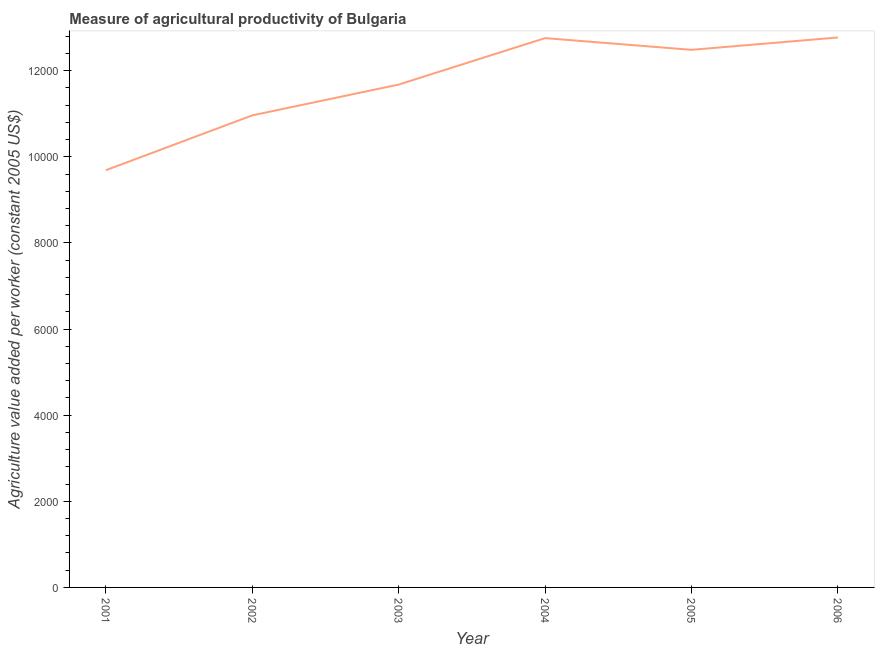What is the agriculture value added per worker in 2006?
Offer a very short reply. 1.28e+04. Across all years, what is the maximum agriculture value added per worker?
Provide a short and direct response. 1.28e+04. Across all years, what is the minimum agriculture value added per worker?
Offer a very short reply. 9690.22. In which year was the agriculture value added per worker maximum?
Give a very brief answer. 2006. What is the sum of the agriculture value added per worker?
Give a very brief answer. 7.04e+04. What is the difference between the agriculture value added per worker in 2001 and 2005?
Provide a short and direct response. -2795.65. What is the average agriculture value added per worker per year?
Offer a terse response. 1.17e+04. What is the median agriculture value added per worker?
Your response must be concise. 1.21e+04. In how many years, is the agriculture value added per worker greater than 5200 US$?
Make the answer very short. 6. Do a majority of the years between 2004 and 2003 (inclusive) have agriculture value added per worker greater than 6400 US$?
Your response must be concise. No. What is the ratio of the agriculture value added per worker in 2001 to that in 2005?
Your answer should be compact. 0.78. Is the agriculture value added per worker in 2001 less than that in 2005?
Give a very brief answer. Yes. What is the difference between the highest and the second highest agriculture value added per worker?
Give a very brief answer. 14.93. What is the difference between the highest and the lowest agriculture value added per worker?
Your answer should be compact. 3083.1. In how many years, is the agriculture value added per worker greater than the average agriculture value added per worker taken over all years?
Your answer should be very brief. 3. Does the agriculture value added per worker monotonically increase over the years?
Ensure brevity in your answer.  No. How many lines are there?
Give a very brief answer. 1. How many years are there in the graph?
Give a very brief answer. 6. What is the difference between two consecutive major ticks on the Y-axis?
Make the answer very short. 2000. Are the values on the major ticks of Y-axis written in scientific E-notation?
Make the answer very short. No. Does the graph contain any zero values?
Provide a succinct answer. No. What is the title of the graph?
Give a very brief answer. Measure of agricultural productivity of Bulgaria. What is the label or title of the Y-axis?
Keep it short and to the point. Agriculture value added per worker (constant 2005 US$). What is the Agriculture value added per worker (constant 2005 US$) in 2001?
Offer a terse response. 9690.22. What is the Agriculture value added per worker (constant 2005 US$) of 2002?
Ensure brevity in your answer.  1.10e+04. What is the Agriculture value added per worker (constant 2005 US$) in 2003?
Ensure brevity in your answer.  1.17e+04. What is the Agriculture value added per worker (constant 2005 US$) of 2004?
Offer a terse response. 1.28e+04. What is the Agriculture value added per worker (constant 2005 US$) of 2005?
Make the answer very short. 1.25e+04. What is the Agriculture value added per worker (constant 2005 US$) of 2006?
Give a very brief answer. 1.28e+04. What is the difference between the Agriculture value added per worker (constant 2005 US$) in 2001 and 2002?
Offer a terse response. -1273.7. What is the difference between the Agriculture value added per worker (constant 2005 US$) in 2001 and 2003?
Ensure brevity in your answer.  -1989.24. What is the difference between the Agriculture value added per worker (constant 2005 US$) in 2001 and 2004?
Make the answer very short. -3068.17. What is the difference between the Agriculture value added per worker (constant 2005 US$) in 2001 and 2005?
Your response must be concise. -2795.65. What is the difference between the Agriculture value added per worker (constant 2005 US$) in 2001 and 2006?
Your answer should be very brief. -3083.1. What is the difference between the Agriculture value added per worker (constant 2005 US$) in 2002 and 2003?
Offer a terse response. -715.54. What is the difference between the Agriculture value added per worker (constant 2005 US$) in 2002 and 2004?
Ensure brevity in your answer.  -1794.47. What is the difference between the Agriculture value added per worker (constant 2005 US$) in 2002 and 2005?
Give a very brief answer. -1521.95. What is the difference between the Agriculture value added per worker (constant 2005 US$) in 2002 and 2006?
Ensure brevity in your answer.  -1809.4. What is the difference between the Agriculture value added per worker (constant 2005 US$) in 2003 and 2004?
Keep it short and to the point. -1078.93. What is the difference between the Agriculture value added per worker (constant 2005 US$) in 2003 and 2005?
Your response must be concise. -806.41. What is the difference between the Agriculture value added per worker (constant 2005 US$) in 2003 and 2006?
Your answer should be compact. -1093.86. What is the difference between the Agriculture value added per worker (constant 2005 US$) in 2004 and 2005?
Your answer should be compact. 272.52. What is the difference between the Agriculture value added per worker (constant 2005 US$) in 2004 and 2006?
Give a very brief answer. -14.93. What is the difference between the Agriculture value added per worker (constant 2005 US$) in 2005 and 2006?
Give a very brief answer. -287.45. What is the ratio of the Agriculture value added per worker (constant 2005 US$) in 2001 to that in 2002?
Provide a short and direct response. 0.88. What is the ratio of the Agriculture value added per worker (constant 2005 US$) in 2001 to that in 2003?
Your answer should be compact. 0.83. What is the ratio of the Agriculture value added per worker (constant 2005 US$) in 2001 to that in 2004?
Your answer should be compact. 0.76. What is the ratio of the Agriculture value added per worker (constant 2005 US$) in 2001 to that in 2005?
Offer a very short reply. 0.78. What is the ratio of the Agriculture value added per worker (constant 2005 US$) in 2001 to that in 2006?
Offer a terse response. 0.76. What is the ratio of the Agriculture value added per worker (constant 2005 US$) in 2002 to that in 2003?
Make the answer very short. 0.94. What is the ratio of the Agriculture value added per worker (constant 2005 US$) in 2002 to that in 2004?
Ensure brevity in your answer.  0.86. What is the ratio of the Agriculture value added per worker (constant 2005 US$) in 2002 to that in 2005?
Ensure brevity in your answer.  0.88. What is the ratio of the Agriculture value added per worker (constant 2005 US$) in 2002 to that in 2006?
Offer a very short reply. 0.86. What is the ratio of the Agriculture value added per worker (constant 2005 US$) in 2003 to that in 2004?
Provide a short and direct response. 0.92. What is the ratio of the Agriculture value added per worker (constant 2005 US$) in 2003 to that in 2005?
Keep it short and to the point. 0.94. What is the ratio of the Agriculture value added per worker (constant 2005 US$) in 2003 to that in 2006?
Your answer should be compact. 0.91. What is the ratio of the Agriculture value added per worker (constant 2005 US$) in 2004 to that in 2006?
Give a very brief answer. 1. What is the ratio of the Agriculture value added per worker (constant 2005 US$) in 2005 to that in 2006?
Provide a succinct answer. 0.98. 